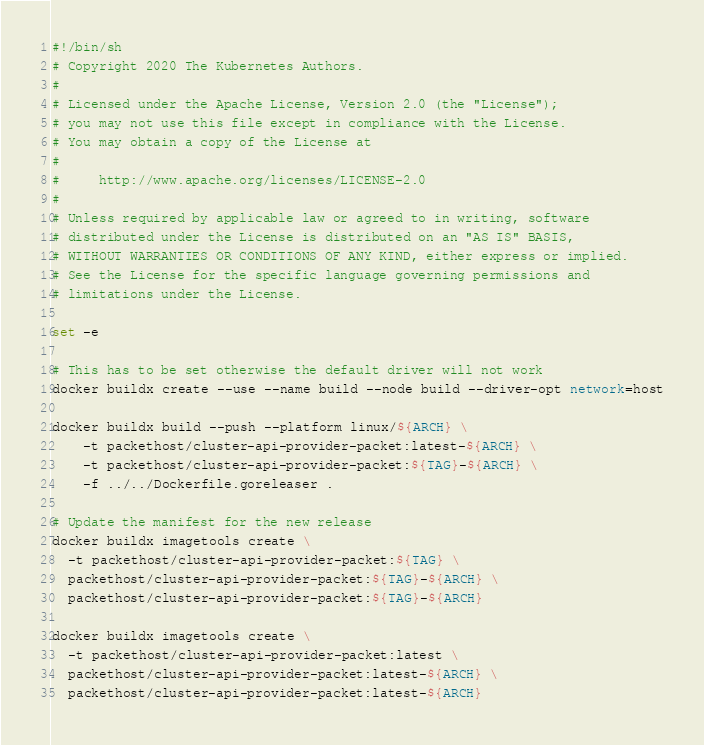Convert code to text. <code><loc_0><loc_0><loc_500><loc_500><_Bash_>#!/bin/sh
# Copyright 2020 The Kubernetes Authors.
#
# Licensed under the Apache License, Version 2.0 (the "License");
# you may not use this file except in compliance with the License.
# You may obtain a copy of the License at
#
#     http://www.apache.org/licenses/LICENSE-2.0
#
# Unless required by applicable law or agreed to in writing, software
# distributed under the License is distributed on an "AS IS" BASIS,
# WITHOUT WARRANTIES OR CONDITIONS OF ANY KIND, either express or implied.
# See the License for the specific language governing permissions and
# limitations under the License.

set -e

# This has to be set otherwise the default driver will not work
docker buildx create --use --name build --node build --driver-opt network=host

docker buildx build --push --platform linux/${ARCH} \
    -t packethost/cluster-api-provider-packet:latest-${ARCH} \
    -t packethost/cluster-api-provider-packet:${TAG}-${ARCH} \
    -f ../../Dockerfile.goreleaser .

# Update the manifest for the new release
docker buildx imagetools create \
  -t packethost/cluster-api-provider-packet:${TAG} \
  packethost/cluster-api-provider-packet:${TAG}-${ARCH} \
  packethost/cluster-api-provider-packet:${TAG}-${ARCH}

docker buildx imagetools create \
  -t packethost/cluster-api-provider-packet:latest \
  packethost/cluster-api-provider-packet:latest-${ARCH} \
  packethost/cluster-api-provider-packet:latest-${ARCH}
</code> 